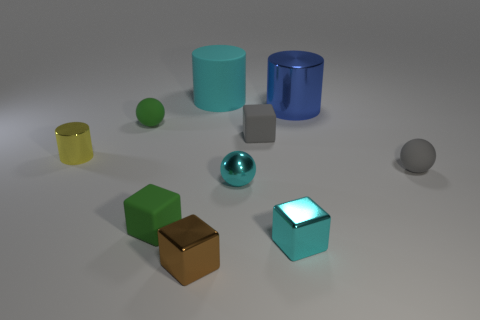What is the color of the ball that is to the right of the large cylinder that is on the right side of the tiny cyan ball?
Provide a short and direct response. Gray. What is the material of the tiny green object that is the same shape as the tiny brown metallic thing?
Offer a terse response. Rubber. How many rubber objects are green things or yellow cylinders?
Give a very brief answer. 2. Is the material of the tiny sphere that is to the left of the large rubber cylinder the same as the ball in front of the small gray matte ball?
Ensure brevity in your answer.  No. Is there a gray block?
Ensure brevity in your answer.  Yes. There is a tiny cyan object that is on the right side of the tiny cyan metal sphere; is it the same shape as the small gray object to the left of the large blue cylinder?
Give a very brief answer. Yes. Are there any other small blocks made of the same material as the small gray block?
Keep it short and to the point. Yes. Does the big cylinder that is behind the large blue metal cylinder have the same material as the blue cylinder?
Offer a terse response. No. Is the number of tiny matte spheres that are left of the cyan block greater than the number of shiny cubes that are in front of the tiny brown cube?
Your response must be concise. Yes. There is a metallic sphere that is the same size as the yellow object; what is its color?
Your answer should be compact. Cyan. 